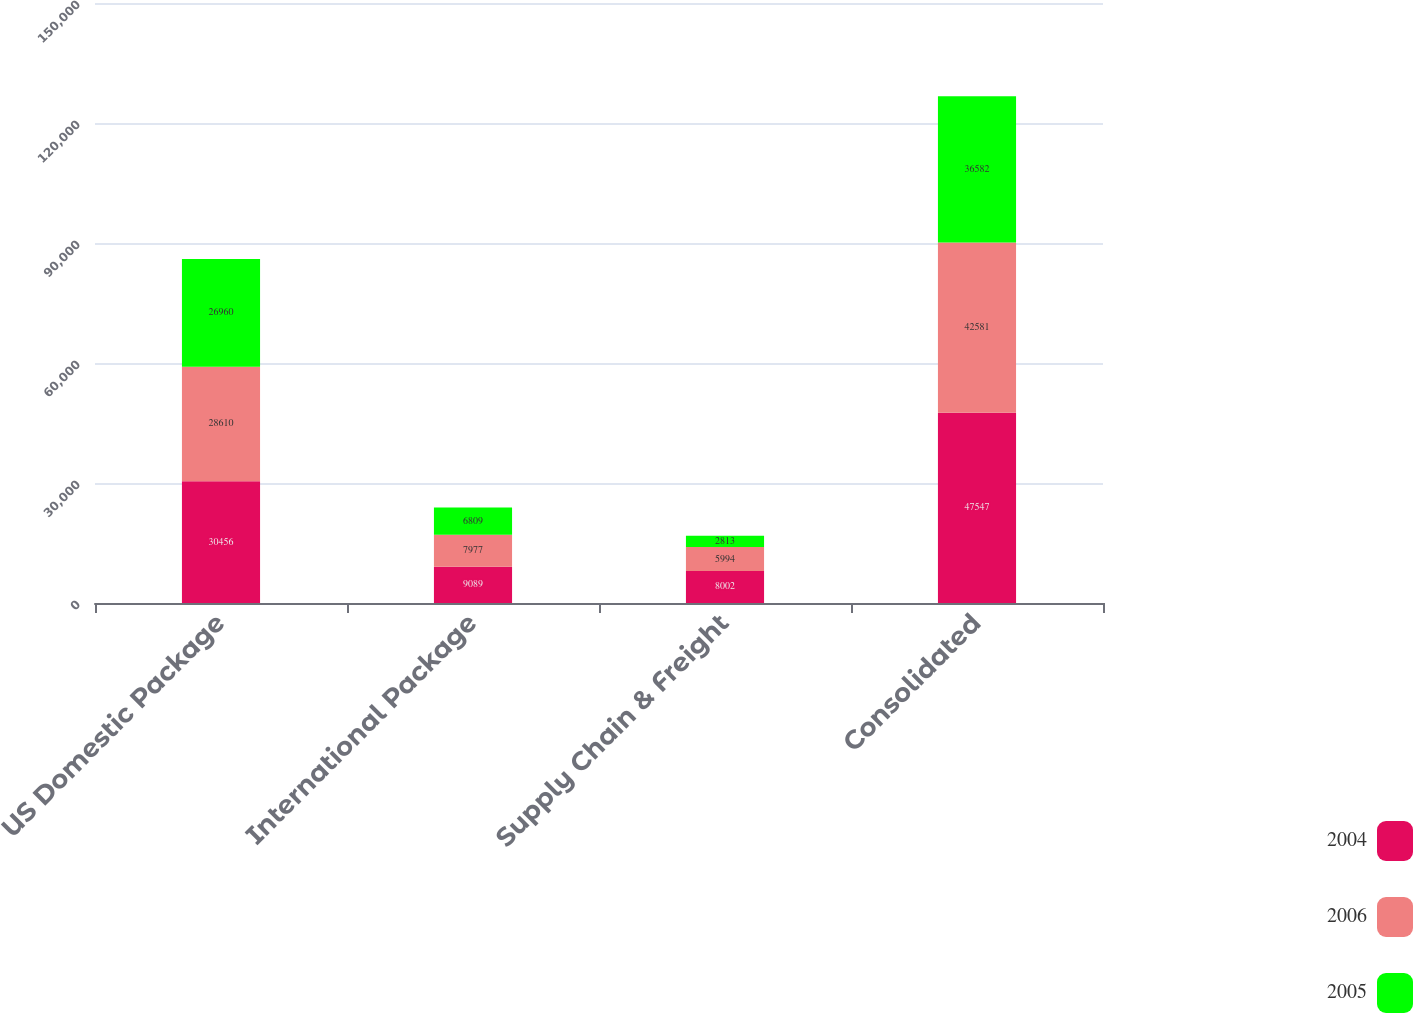Convert chart to OTSL. <chart><loc_0><loc_0><loc_500><loc_500><stacked_bar_chart><ecel><fcel>US Domestic Package<fcel>International Package<fcel>Supply Chain & Freight<fcel>Consolidated<nl><fcel>2004<fcel>30456<fcel>9089<fcel>8002<fcel>47547<nl><fcel>2006<fcel>28610<fcel>7977<fcel>5994<fcel>42581<nl><fcel>2005<fcel>26960<fcel>6809<fcel>2813<fcel>36582<nl></chart> 